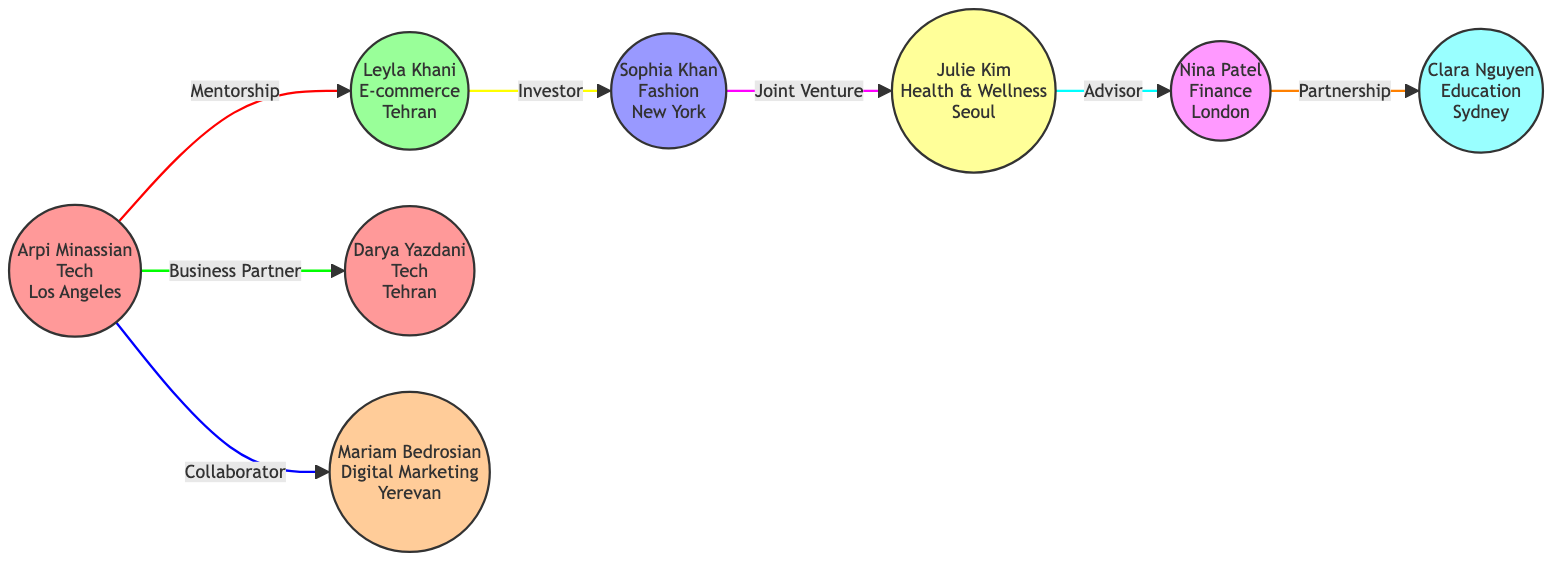What's the total number of nodes in the diagram? The diagram presents a total of 8 unique nodes, each representing a successful female entrepreneur. These include Arpi Minassian, Leyla Khani, Sophia Khan, Julie Kim, Nina Patel, Clara Nguyen, Darya Yazdani, and Mariam Bedrosian.
Answer: 8 Which entrepreneur in the tech industry is located in Tehran? Darya Yazdani is the entrepreneur specified in the tech industry who is located in Tehran, as depicted in the diagram.
Answer: Darya Yazdani What type of relationship exists between Leyla Khani and Sophia Khan? The diagram clearly shows that Leyla Khani has an investor relationship with Sophia Khan, indicated by the connecting line and the label on it.
Answer: Investor How many different industries are represented among the entrepreneurs? The diagram features 7 distinct industries: Tech, E-commerce, Fashion, Health & Wellness, Finance, Education, and Digital Marketing.
Answer: 7 Who is a collaborator of Arpi Minassian? The link in the diagram indicates that Mariam Bedrosian is a collaborator of Arpi Minassian because the line labeled "Collaborator" connects these two nodes.
Answer: Mariam Bedrosian Which entrepreneur acts as an advisor to Nina Patel? According to the diagram, Julie Kim functions as an advisor to Nina Patel, as shown by the directed edge labeled "Advisor" between them.
Answer: Julie Kim Which node has the most connections in the diagram? Analyzing the connections, Arpi Minassian has three direct relationships (with Leyla Khani, Darya Yazdani, and Mariam Bedrosian), making it the node with the most connections.
Answer: Arpi Minassian What is the relationship type between Sophia Khan and Julie Kim? The diagram illustrates that Sophia Khan and Julie Kim have a joint venture relationship, indicated by the connection labeled as "Joint Venture."
Answer: Joint Venture 